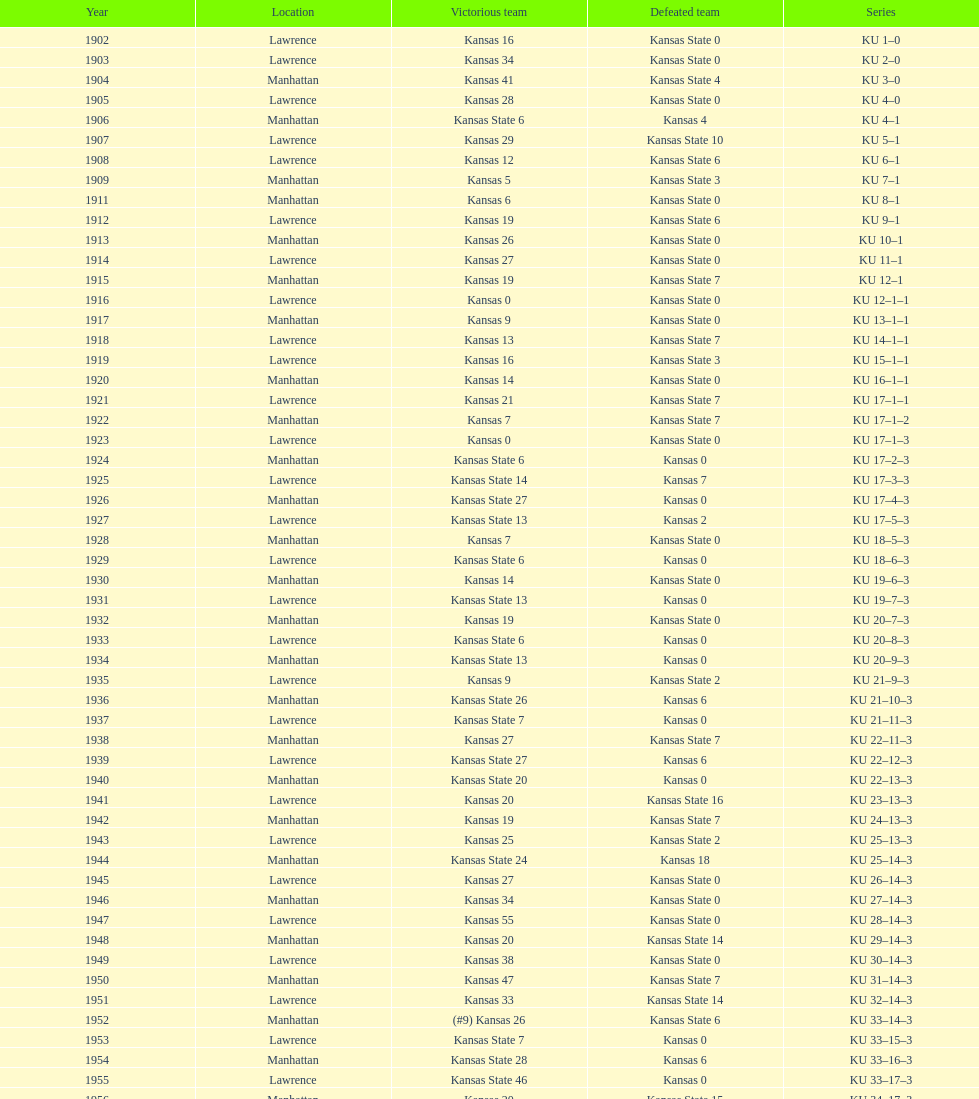When was the first game that kansas state won by double digits? 1926. 